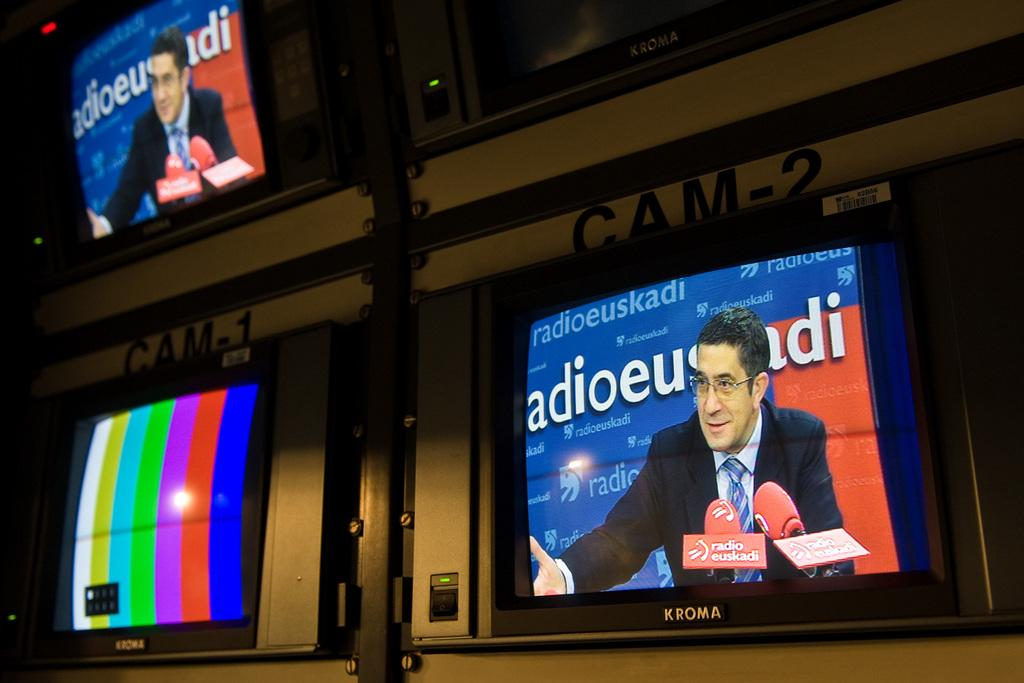<image>
Relay a brief, clear account of the picture shown. A Kroma brand TV showing a man in a press conference with radio euskadi. 